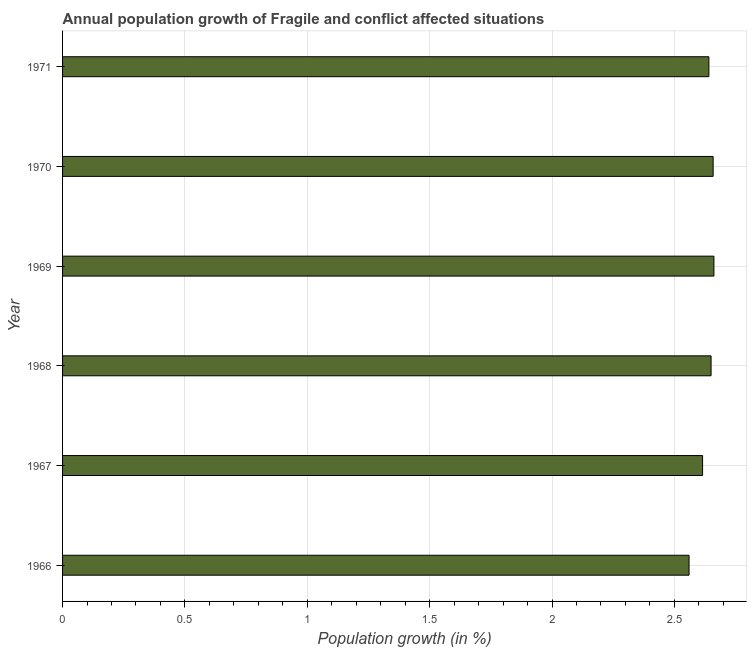Does the graph contain any zero values?
Your answer should be compact. No. What is the title of the graph?
Your response must be concise. Annual population growth of Fragile and conflict affected situations. What is the label or title of the X-axis?
Provide a short and direct response. Population growth (in %). What is the label or title of the Y-axis?
Ensure brevity in your answer.  Year. What is the population growth in 1970?
Provide a short and direct response. 2.66. Across all years, what is the maximum population growth?
Provide a succinct answer. 2.66. Across all years, what is the minimum population growth?
Provide a succinct answer. 2.56. In which year was the population growth maximum?
Offer a very short reply. 1969. In which year was the population growth minimum?
Provide a succinct answer. 1966. What is the sum of the population growth?
Provide a short and direct response. 15.79. What is the difference between the population growth in 1969 and 1970?
Your answer should be very brief. 0. What is the average population growth per year?
Your answer should be very brief. 2.63. What is the median population growth?
Offer a terse response. 2.65. In how many years, is the population growth greater than 1.3 %?
Your response must be concise. 6. Do a majority of the years between 1966 and 1969 (inclusive) have population growth greater than 2.4 %?
Provide a succinct answer. Yes. What is the ratio of the population growth in 1968 to that in 1971?
Ensure brevity in your answer.  1. Is the population growth in 1969 less than that in 1971?
Offer a terse response. No. Is the difference between the population growth in 1970 and 1971 greater than the difference between any two years?
Your answer should be compact. No. What is the difference between the highest and the second highest population growth?
Make the answer very short. 0. In how many years, is the population growth greater than the average population growth taken over all years?
Offer a terse response. 4. How many bars are there?
Provide a succinct answer. 6. What is the Population growth (in %) in 1966?
Offer a terse response. 2.56. What is the Population growth (in %) in 1967?
Offer a very short reply. 2.62. What is the Population growth (in %) in 1968?
Provide a short and direct response. 2.65. What is the Population growth (in %) in 1969?
Your answer should be very brief. 2.66. What is the Population growth (in %) in 1970?
Offer a very short reply. 2.66. What is the Population growth (in %) in 1971?
Make the answer very short. 2.64. What is the difference between the Population growth (in %) in 1966 and 1967?
Ensure brevity in your answer.  -0.06. What is the difference between the Population growth (in %) in 1966 and 1968?
Give a very brief answer. -0.09. What is the difference between the Population growth (in %) in 1966 and 1969?
Your answer should be compact. -0.1. What is the difference between the Population growth (in %) in 1966 and 1970?
Your answer should be compact. -0.1. What is the difference between the Population growth (in %) in 1966 and 1971?
Keep it short and to the point. -0.08. What is the difference between the Population growth (in %) in 1967 and 1968?
Your answer should be compact. -0.03. What is the difference between the Population growth (in %) in 1967 and 1969?
Your answer should be compact. -0.05. What is the difference between the Population growth (in %) in 1967 and 1970?
Your answer should be very brief. -0.04. What is the difference between the Population growth (in %) in 1967 and 1971?
Offer a very short reply. -0.03. What is the difference between the Population growth (in %) in 1968 and 1969?
Make the answer very short. -0.01. What is the difference between the Population growth (in %) in 1968 and 1970?
Your answer should be compact. -0.01. What is the difference between the Population growth (in %) in 1968 and 1971?
Provide a succinct answer. 0.01. What is the difference between the Population growth (in %) in 1969 and 1970?
Offer a terse response. 0. What is the difference between the Population growth (in %) in 1969 and 1971?
Offer a very short reply. 0.02. What is the difference between the Population growth (in %) in 1970 and 1971?
Provide a short and direct response. 0.02. What is the ratio of the Population growth (in %) in 1966 to that in 1967?
Offer a terse response. 0.98. What is the ratio of the Population growth (in %) in 1966 to that in 1968?
Keep it short and to the point. 0.97. What is the ratio of the Population growth (in %) in 1966 to that in 1970?
Your response must be concise. 0.96. What is the ratio of the Population growth (in %) in 1966 to that in 1971?
Offer a very short reply. 0.97. What is the ratio of the Population growth (in %) in 1967 to that in 1969?
Offer a very short reply. 0.98. What is the ratio of the Population growth (in %) in 1967 to that in 1971?
Your answer should be compact. 0.99. What is the ratio of the Population growth (in %) in 1969 to that in 1970?
Offer a very short reply. 1. 